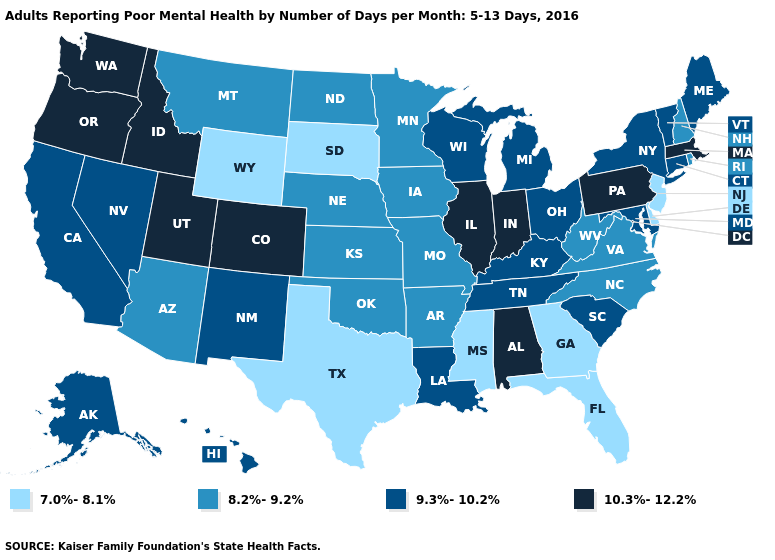What is the value of Mississippi?
Give a very brief answer. 7.0%-8.1%. Among the states that border Colorado , does Utah have the highest value?
Concise answer only. Yes. Name the states that have a value in the range 10.3%-12.2%?
Write a very short answer. Alabama, Colorado, Idaho, Illinois, Indiana, Massachusetts, Oregon, Pennsylvania, Utah, Washington. Does Washington have the same value as New York?
Quick response, please. No. Does Ohio have the lowest value in the USA?
Keep it brief. No. What is the value of Pennsylvania?
Be succinct. 10.3%-12.2%. What is the value of Idaho?
Concise answer only. 10.3%-12.2%. Which states have the highest value in the USA?
Write a very short answer. Alabama, Colorado, Idaho, Illinois, Indiana, Massachusetts, Oregon, Pennsylvania, Utah, Washington. What is the value of Missouri?
Keep it brief. 8.2%-9.2%. What is the value of Delaware?
Short answer required. 7.0%-8.1%. What is the value of California?
Quick response, please. 9.3%-10.2%. Does South Carolina have the same value as Alabama?
Keep it brief. No. Is the legend a continuous bar?
Write a very short answer. No. Name the states that have a value in the range 9.3%-10.2%?
Give a very brief answer. Alaska, California, Connecticut, Hawaii, Kentucky, Louisiana, Maine, Maryland, Michigan, Nevada, New Mexico, New York, Ohio, South Carolina, Tennessee, Vermont, Wisconsin. Which states have the lowest value in the West?
Answer briefly. Wyoming. 